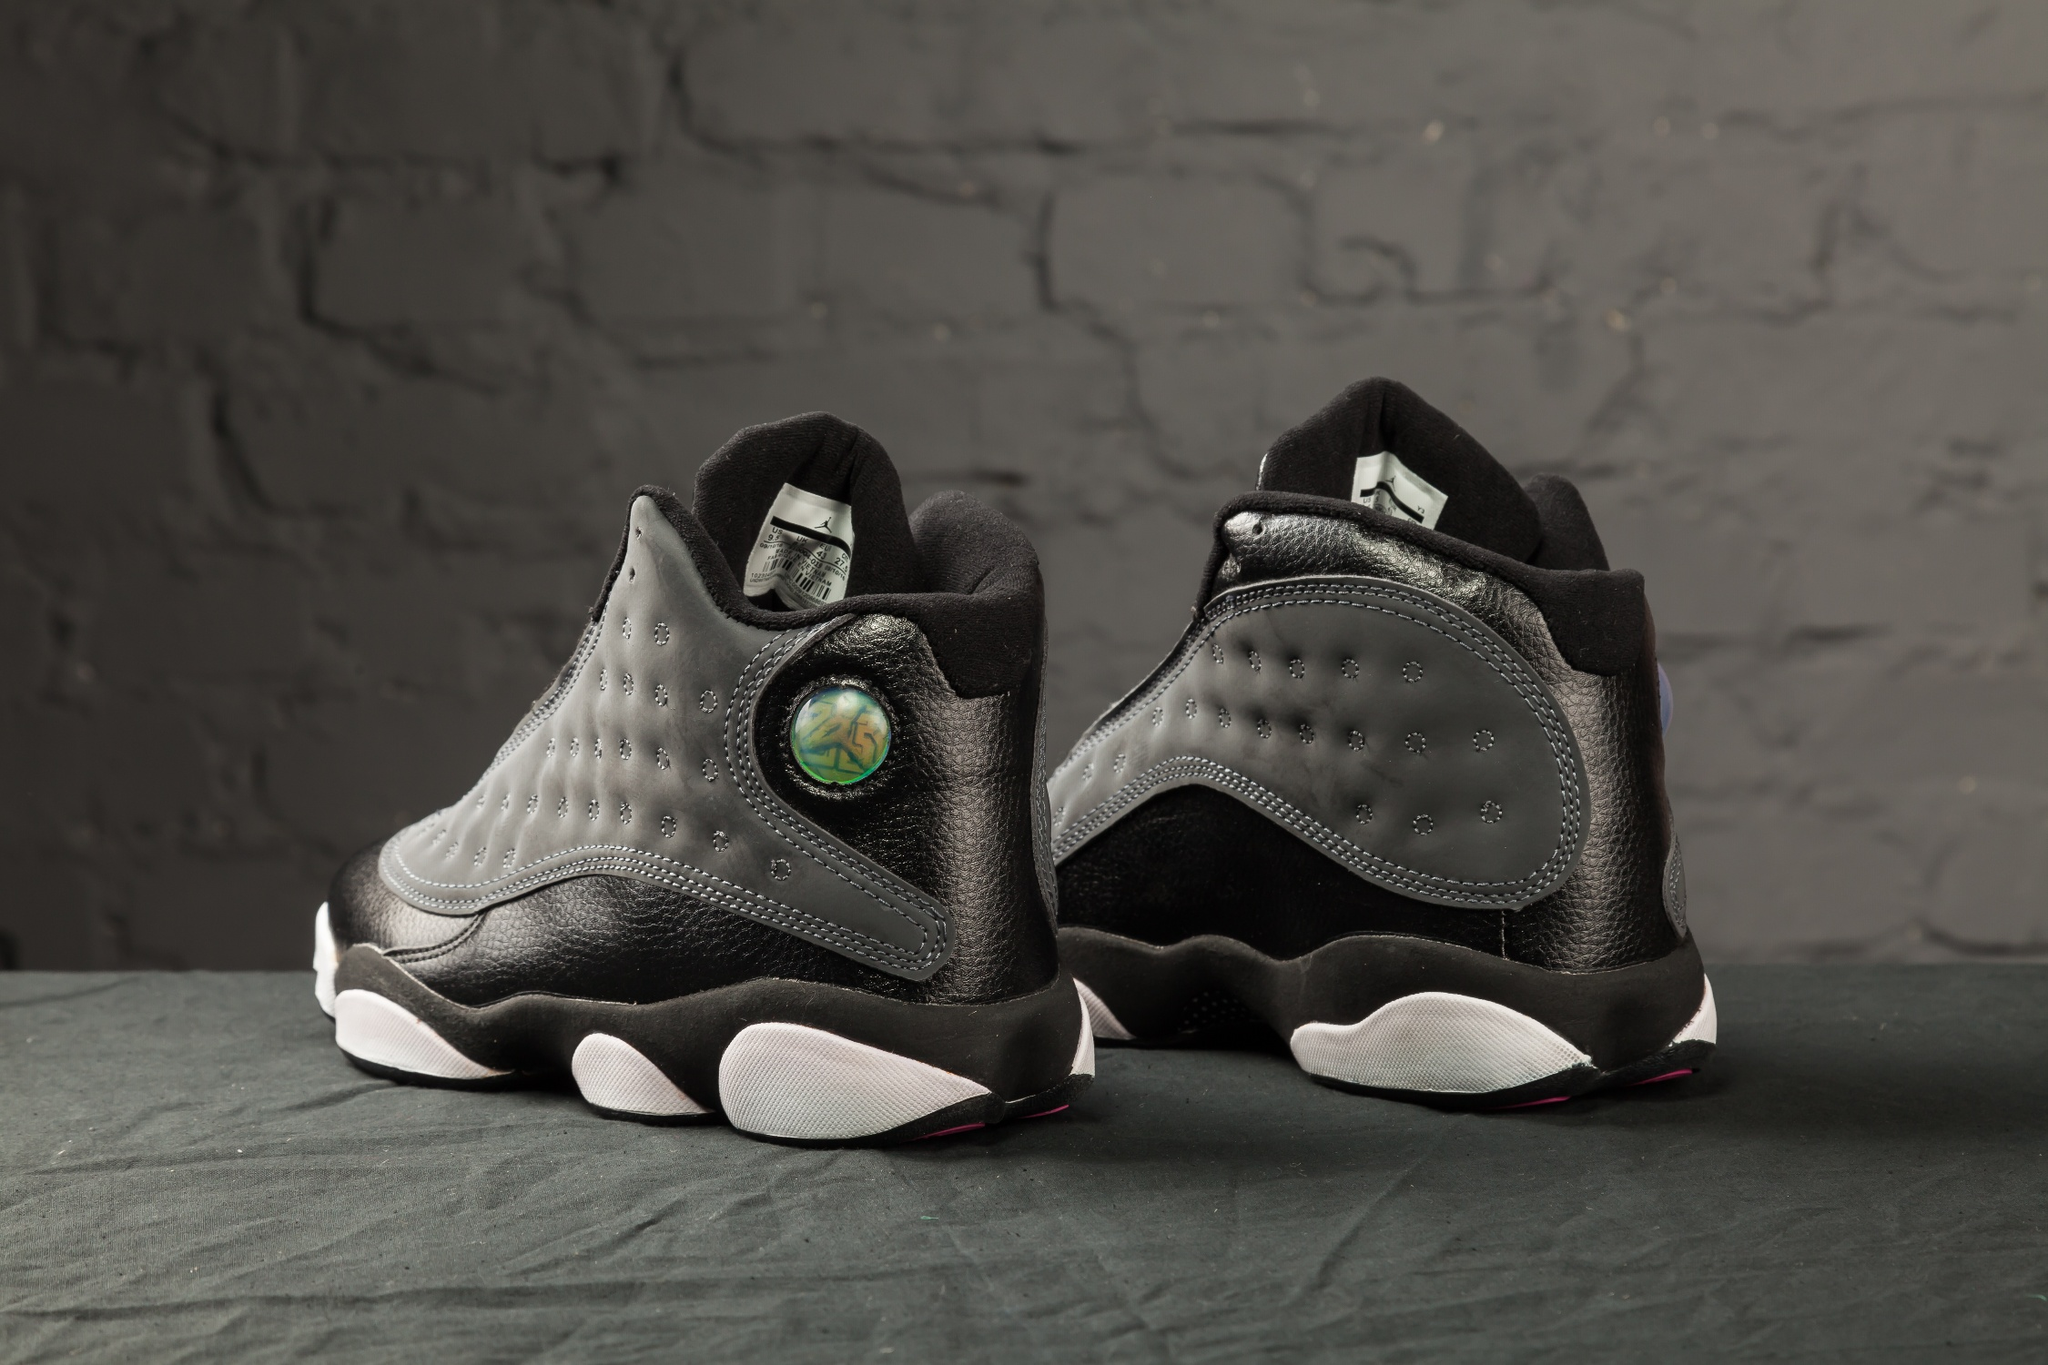Tell a story inspired by these sneakers. In a city that never sleeps, amidst the towering skyscrapers and bustling streets, there lived a young artist named Alex. They weren’t just an ordinary artist but a dreamer who saw potential and beauty in the mundane. One day, Alex found a pair of sneakers tucked away in a vintage store, covered in a layer of dust but radiating an aura of mystery. With a holographic logo that shimmered under the shop's lights, the sneakers seemed to whisper tales of adventures waiting to be had. Alex purchased the sneakers and wore them everywhere. They walked through forgotten alleys, capturing the essence of urban life in their sketches and photographs. Each step in those sneakers was a new experience, a new story waiting to unfold. Alex became known for their urban art, a blend of dreams and reality, all thanks to the inspiration provided by those remarkable sneakers. How would a sneakerhead describe these shoes in a single sentence? These sneakers are a perfect fusion of urban chic and futuristic design, spotlighting a holographic accent that sets them apart. What futuristic features could these sneakers have? Imagine these sneakers being equipped with augmented reality capabilities, where the holographic logo acts as a HUD (Heads-Up Display) projecting real-time data like navigation, messages, and even virtual graffiti art onto the surroundings. The soles could have adaptive grip technology that adjusts to different terrains, ensuring stability and comfort. Additionally, built-in kinetic energy chargers in the soles could power small devices, making these sneakers not only a fashion statement but also a tech marvel of the future. 